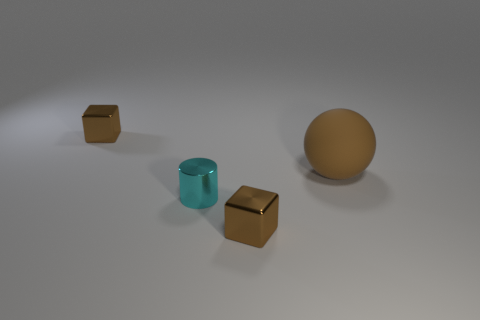Add 4 big brown matte things. How many objects exist? 8 Subtract all cylinders. How many objects are left? 3 Add 4 brown balls. How many brown balls are left? 5 Add 1 large purple metallic cubes. How many large purple metallic cubes exist? 1 Subtract 0 red spheres. How many objects are left? 4 Subtract all large purple metal spheres. Subtract all tiny brown things. How many objects are left? 2 